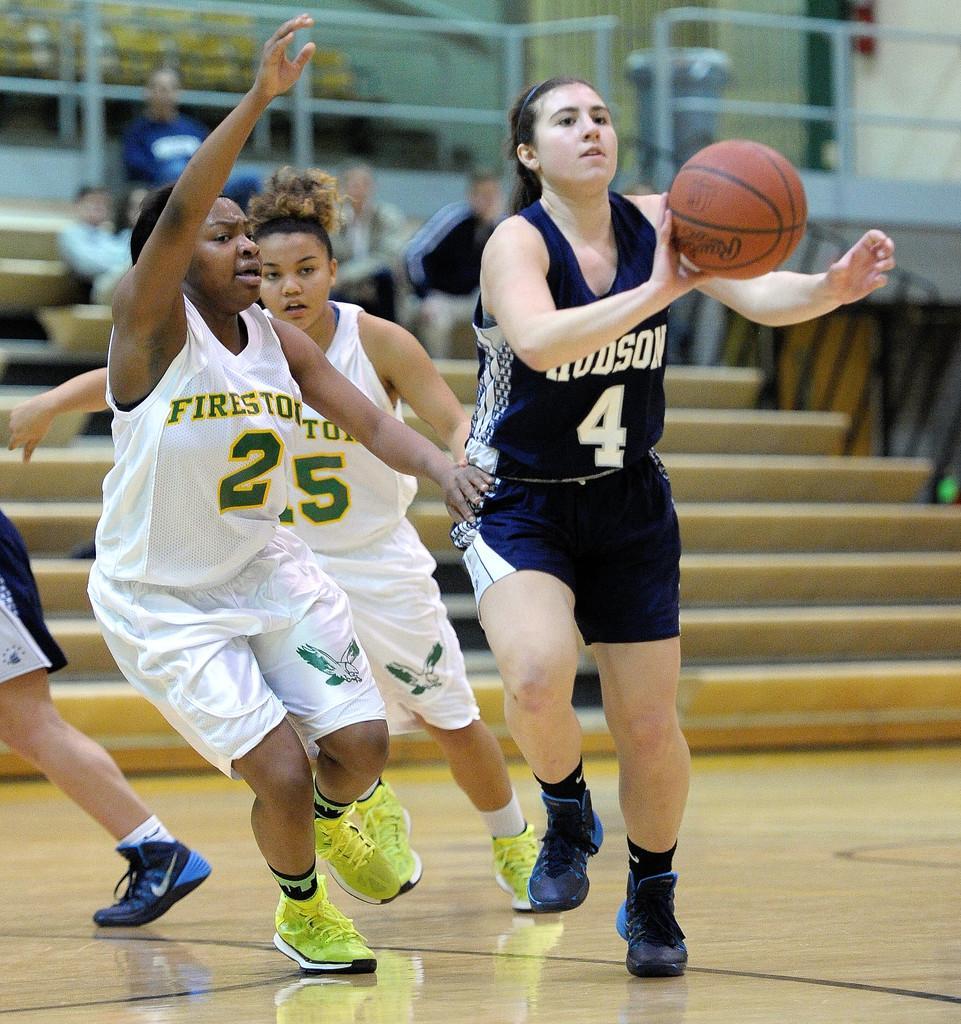Describe this image in one or two sentences. In this image we can see a group of people standing on the floor. To the right side of the image we can see a ball, metal barricades. In the background, we can see a group of people sitting on staircase and a trash bin. 